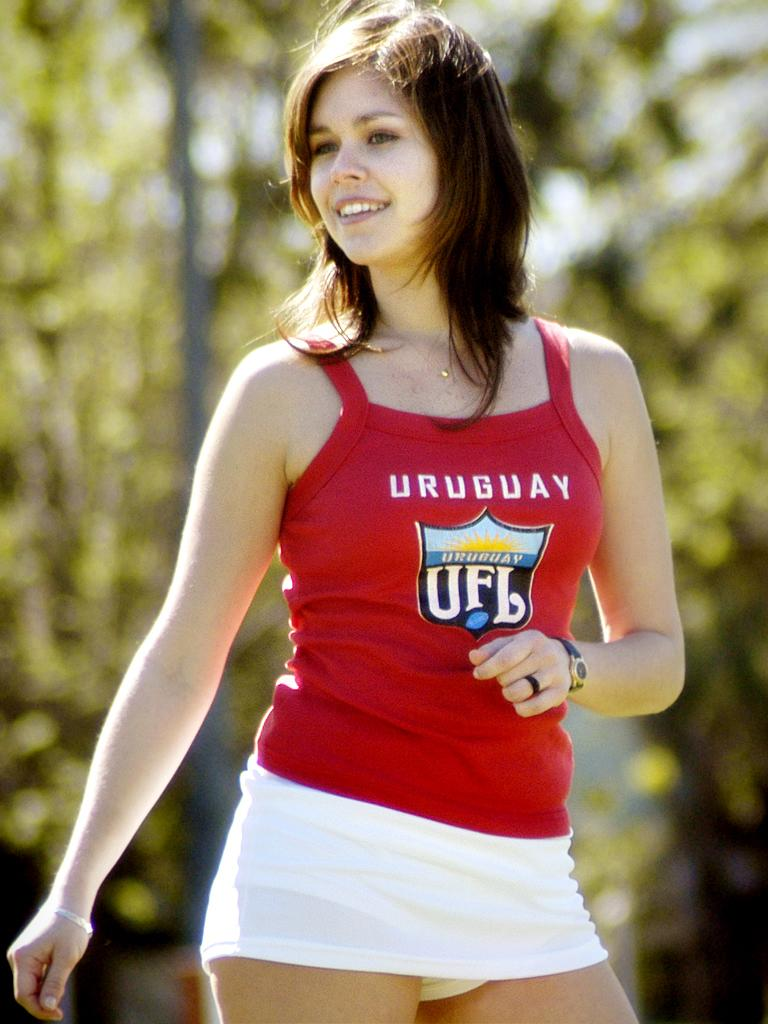<image>
Offer a succinct explanation of the picture presented. a girl wearing a red tank top that says 'uruguay' on it 